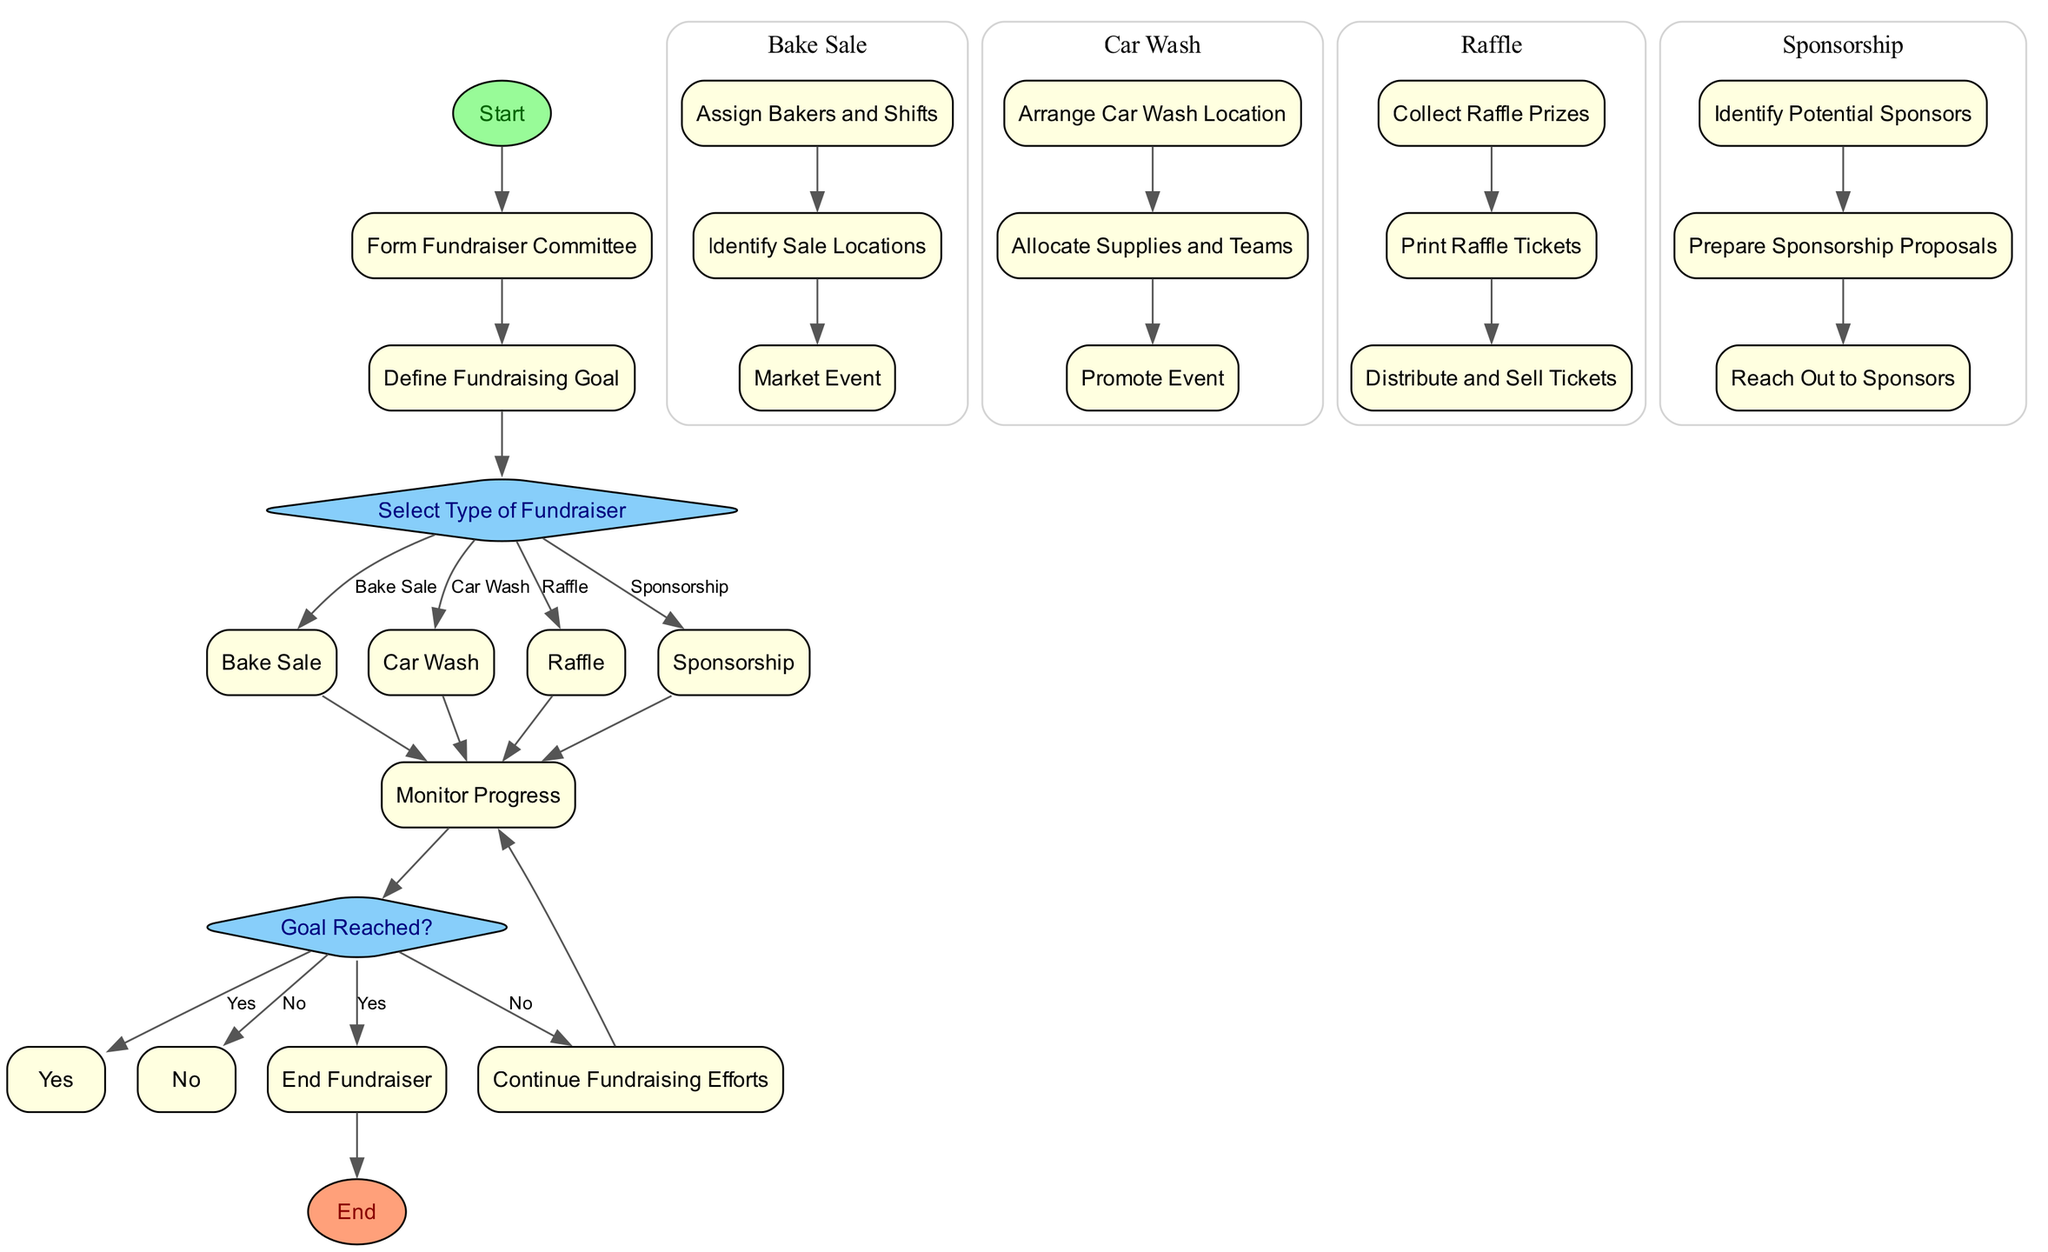What is the first step in the fundraising process? The diagram indicates that the first step is labeled "Start," which later leads to forming the Fundraiser Committee.
Answer: Start How many types of fundraisers are considered in the diagram? The diagram lists four types of fundraisers: Bake Sale, Car Wash, Raffle, and Sponsorship. This indicates that there are a total of four options selectable at the decision point.
Answer: Four What process occurs after assigning bakers and shifts? Within the Bake Sale process, after "Assign Bakers and Shifts," the next step is "Identify Sale Locations." This follows the sequential order of sub-processes under the Bake Sale.
Answer: Identify Sale Locations Which decision leads to ending the fundraiser? The decision node labeled "Goal Reached?" has a 'Yes' option leading to the node "End Fundraiser." This signifies that if the goal is reached, the fundraiser will conclude.
Answer: Yes If the goal is not reached, what is the next action? The 'No' option at the "Goal Reached?" decision leads to "Continue Fundraising Efforts," indicating a loop back to tackle further fundraising until the goal is achieved.
Answer: Continue Fundraising Efforts How many sub-processes are there under the Car Wash? The Car Wash process includes three sub-processes: "Arrange Car Wash Location," "Allocate Supplies and Teams," and "Promote Event." This shows that there are three distinct steps involved in this fundraising type.
Answer: Three What is the final node in the fundraiser coordination flowchart? The flowchart concludes with the node labeled "End," representing the termination point of the fundraising process after the end of all activities.
Answer: End Which fundraising type does not involve selling items directly? Among the fundraiser types, "Sponsorship" is the only one that does not involve selling items, as it focuses on obtaining support from businesses or individuals.
Answer: Sponsorship What indicates a process or decision in this flowchart? Processes are represented by rectangles, while decision points are shown as diamonds. This visual distinction helps to identify the types of actions or evaluations taking place in the flowchart.
Answer: Rectangles and diamonds 